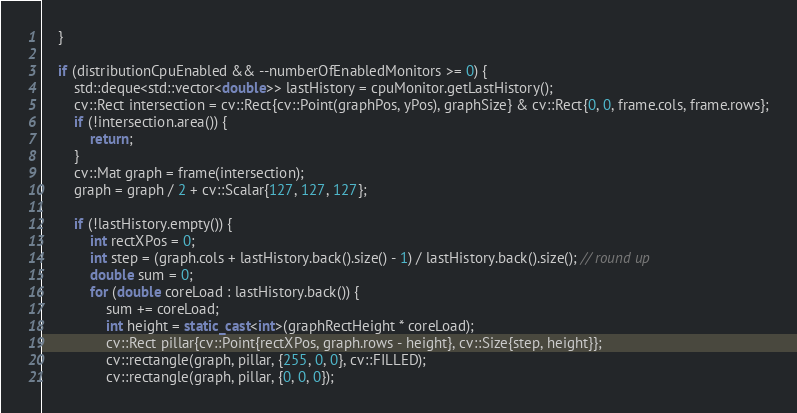Convert code to text. <code><loc_0><loc_0><loc_500><loc_500><_C++_>    }

    if (distributionCpuEnabled && --numberOfEnabledMonitors >= 0) {
        std::deque<std::vector<double>> lastHistory = cpuMonitor.getLastHistory();
        cv::Rect intersection = cv::Rect{cv::Point(graphPos, yPos), graphSize} & cv::Rect{0, 0, frame.cols, frame.rows};
        if (!intersection.area()) {
            return;
        }
        cv::Mat graph = frame(intersection);
        graph = graph / 2 + cv::Scalar{127, 127, 127};

        if (!lastHistory.empty()) {
            int rectXPos = 0;
            int step = (graph.cols + lastHistory.back().size() - 1) / lastHistory.back().size(); // round up
            double sum = 0;
            for (double coreLoad : lastHistory.back()) {
                sum += coreLoad;
                int height = static_cast<int>(graphRectHeight * coreLoad);
                cv::Rect pillar{cv::Point{rectXPos, graph.rows - height}, cv::Size{step, height}};
                cv::rectangle(graph, pillar, {255, 0, 0}, cv::FILLED);
                cv::rectangle(graph, pillar, {0, 0, 0});</code> 